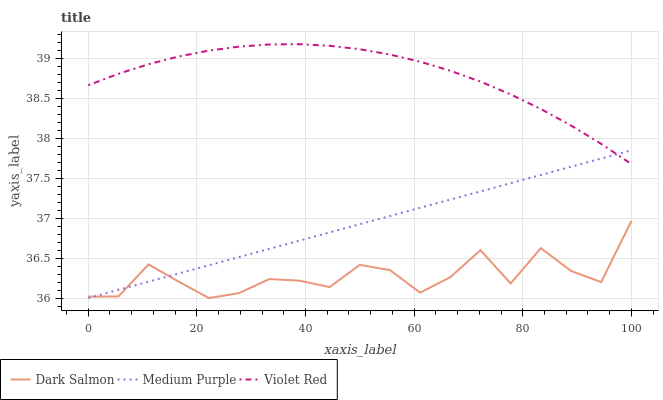Does Dark Salmon have the minimum area under the curve?
Answer yes or no. Yes. Does Violet Red have the maximum area under the curve?
Answer yes or no. Yes. Does Violet Red have the minimum area under the curve?
Answer yes or no. No. Does Dark Salmon have the maximum area under the curve?
Answer yes or no. No. Is Medium Purple the smoothest?
Answer yes or no. Yes. Is Dark Salmon the roughest?
Answer yes or no. Yes. Is Violet Red the smoothest?
Answer yes or no. No. Is Violet Red the roughest?
Answer yes or no. No. Does Medium Purple have the lowest value?
Answer yes or no. Yes. Does Violet Red have the lowest value?
Answer yes or no. No. Does Violet Red have the highest value?
Answer yes or no. Yes. Does Dark Salmon have the highest value?
Answer yes or no. No. Is Dark Salmon less than Violet Red?
Answer yes or no. Yes. Is Violet Red greater than Dark Salmon?
Answer yes or no. Yes. Does Medium Purple intersect Dark Salmon?
Answer yes or no. Yes. Is Medium Purple less than Dark Salmon?
Answer yes or no. No. Is Medium Purple greater than Dark Salmon?
Answer yes or no. No. Does Dark Salmon intersect Violet Red?
Answer yes or no. No. 